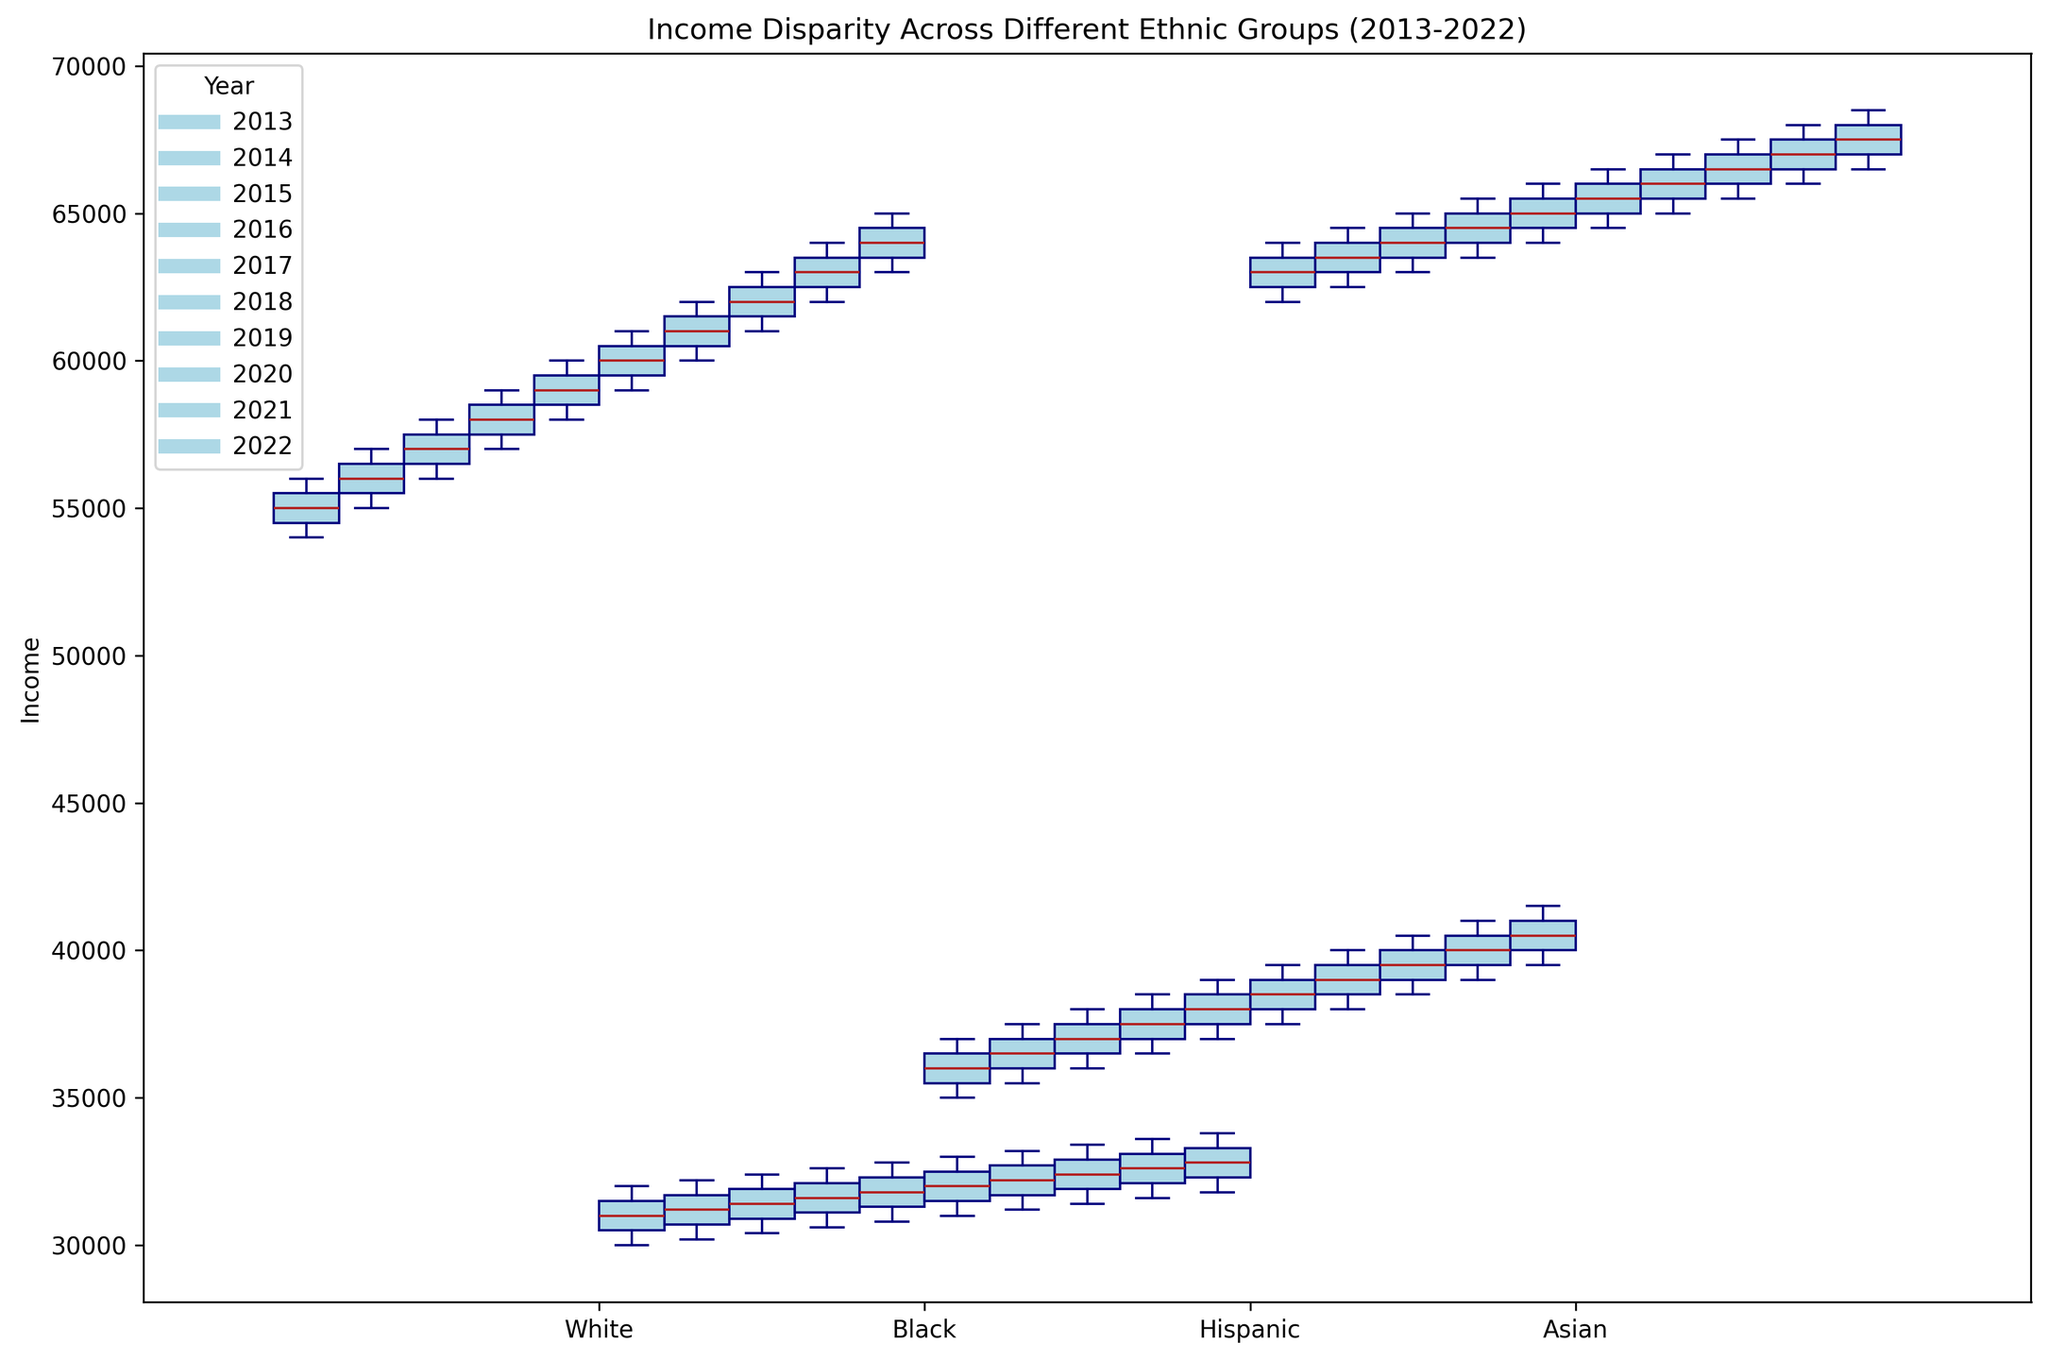Which ethnic group shows the highest median income across all the years? To find the highest median income across all ethnic groups, visually inspect the central line (median) within the boxes across different years and ethnic groups. The Asian group consistently has the highest median line above others.
Answer: Asian How does the income disparity between White and Black ethnic groups change over the decade? To assess the change in income disparity between White and Black ethnic groups, compare the median lines for these groups over the years. The median income in the White group steadily increases from $54,000 in 2013 to $63,000 in 2022, while the Black group's median income rises more slowly from $32,000 to around $33,800. This indicates that while both groups saw income increases, the disparity between them has widened over the decade.
Answer: Income disparity widened Which group has the widest range of incomes in 2022? To determine the widest range, look at the length of the whiskers and interquartile range (IQR) within each boxplot for the year 2022. The White group shows the widest range, as its whiskers cover a more extensive area from around $63,000 to $65,000.
Answer: White What is the median income for the Hispanic ethnic group in 2017? Find the box that represents the Hispanic group for the year 2017 and look at the central line (median) within the box. The median line is at $38,000.
Answer: $38,000 Compare the income ranges for Hispanic and Asian groups in 2020. Which group shows greater income variability? Look at the length of the whiskers and the height of the boxes for both Hispanic and Asian groups in 2020. The Asian group's range spans from $65,500 to $67,500, while the Hispanic group's range is from $38,500 to $40,500. The broader range in the Asian group indicates greater variability.
Answer: Asian Which ethnic group has the narrowest interquartile range (IQR) in 2015? To find the narrowest IQR, check across ethnic groups for the year 2015 and compare the height of the boxes. The White group's box is the shortest, indicating the narrowest IQR.
Answer: White What was the median income change for the Asian ethnic group from 2013 to 2022? Compare the median lines (central lines within the boxes) for the Asian group in 2013 and 2022. In 2013, the median income is around $63,000, while in 2022, it is $67,500, showing an increase of $4,500.
Answer: $4,500 increase Which ethnic group consistently has the lowest income? Inspect the median lines of all groups across all years to identify the lowest income consistently shown. The Black ethnic group continuously has the lowest median income.
Answer: Black What visual attribute indicates the year in the box plot? To identify the year, note the color and position of the box plots. The color light blue is used for all box plots, and the specific year is indicated in the legend. Each year is represented by a different position within the ethnic groups.
Answer: Position in the plot Between the White and Hispanic ethnic groups, which group had a higher percentage increase in median income from 2013 to 2022? Compute the percentage increase for both groups. For the White group, the median increases from $54,000 to $63,000, giving a percentage increase of \((63,000 - 54,000)/54,000 \times 100 = 16.67%\). For the Hispanic group, the median increases from $35,000 to $39,500, giving a percentage increase of \((39,500 - 35,000)/35,000 \times 100 = 12.86%\). Thus, the White group had a higher percentage increase.
Answer: White 